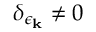<formula> <loc_0><loc_0><loc_500><loc_500>\delta _ { \epsilon _ { k } } \neq 0</formula> 